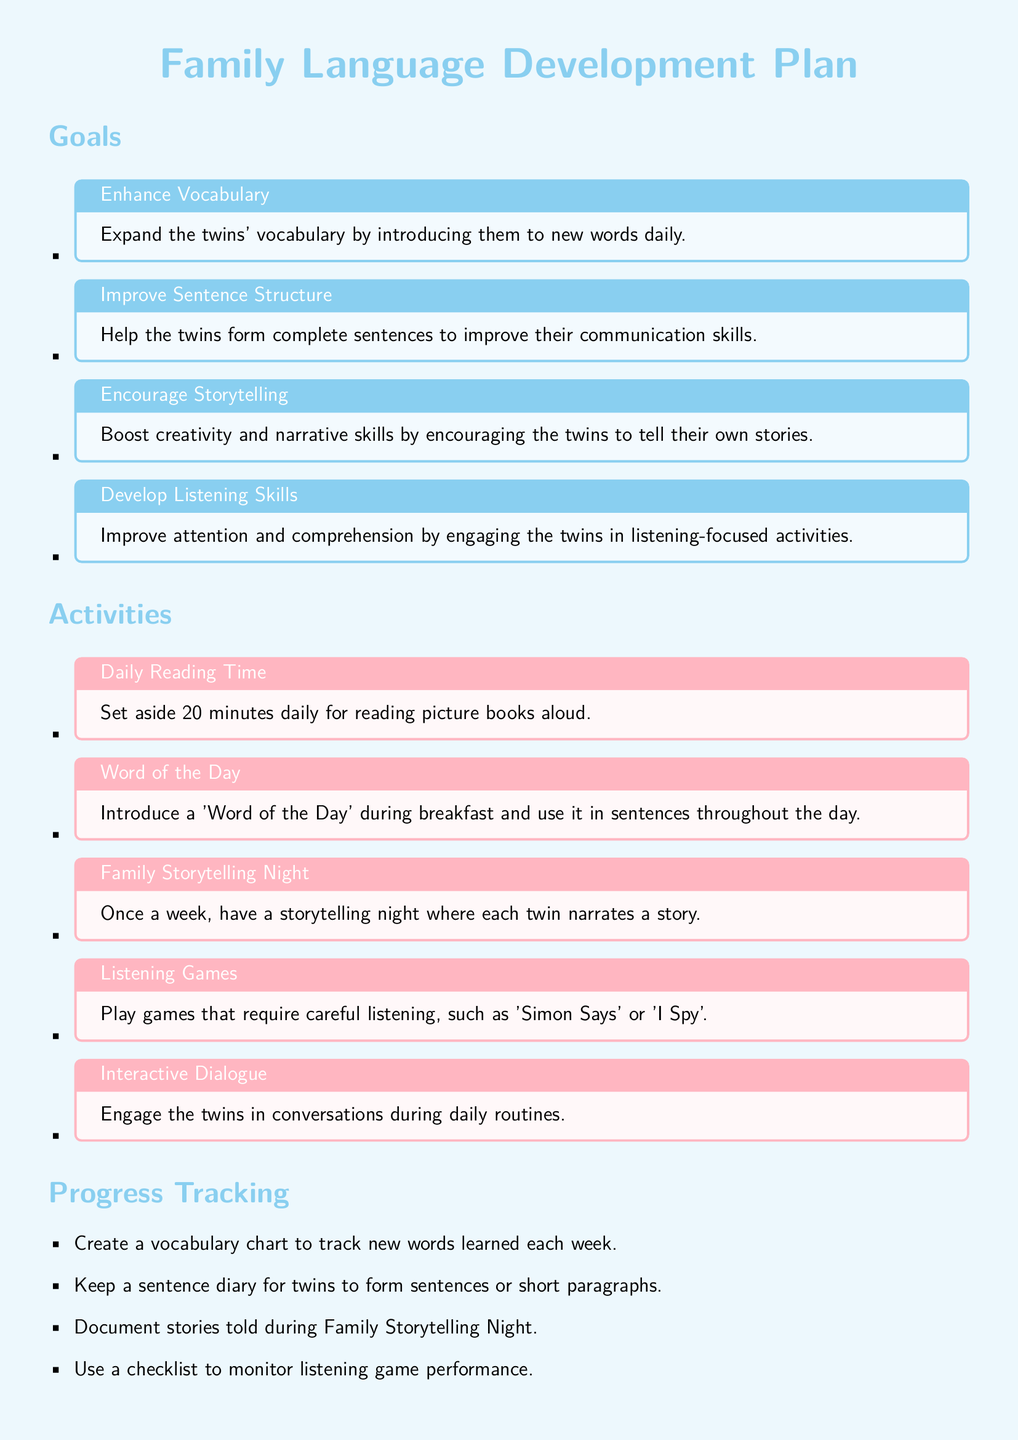what is one of the goals for the twins' language development? One of the goals listed is to expand the twins' vocabulary daily.
Answer: expand the twins' vocabulary how often should Family Storytelling Night occur? The document states that Family Storytelling Night should happen once a week.
Answer: once a week what is the duration of daily reading time suggested? The document specifies setting aside 20 minutes daily for reading picture books aloud.
Answer: 20 minutes what activity involves introducing a 'Word of the Day'? The 'Word of the Day' activity is conducted during breakfast.
Answer: during breakfast how can progress in vocabulary be tracked? A vocabulary chart is suggested to track new words learned each week.
Answer: vocabulary chart which game encourages listening among the twins? 'Simon Says' is mentioned as a game that requires careful listening.
Answer: Simon Says how many main goals are specified in the document? The document lists four main goals for the twins’ language development.
Answer: four what should be maintained to document parent observations? The document suggests maintaining a notebook for parent observations.
Answer: notebook what is the aim of the activity called Interactive Dialogue? The activity aims to engage the twins in conversations during daily routines.
Answer: engage in conversations 